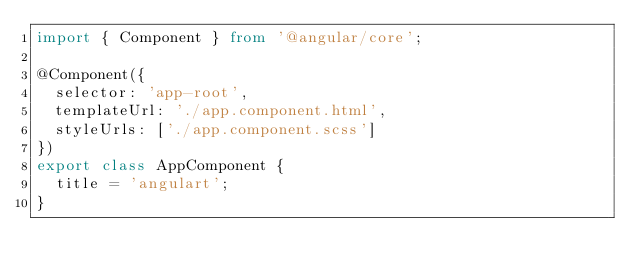Convert code to text. <code><loc_0><loc_0><loc_500><loc_500><_TypeScript_>import { Component } from '@angular/core';

@Component({
  selector: 'app-root',
  templateUrl: './app.component.html',
  styleUrls: ['./app.component.scss']
})
export class AppComponent {
  title = 'angulart';
}
</code> 